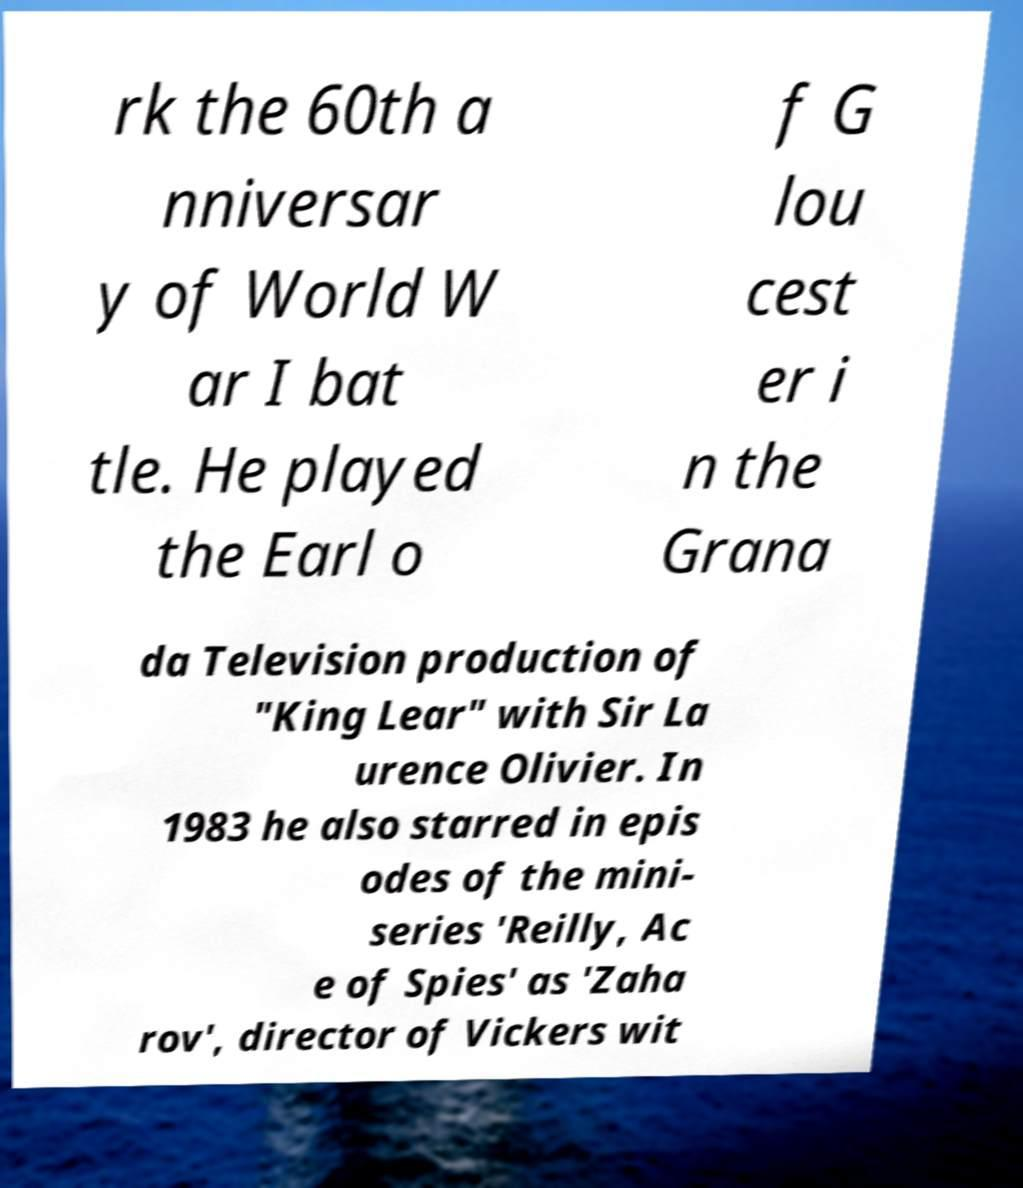Can you read and provide the text displayed in the image?This photo seems to have some interesting text. Can you extract and type it out for me? rk the 60th a nniversar y of World W ar I bat tle. He played the Earl o f G lou cest er i n the Grana da Television production of "King Lear" with Sir La urence Olivier. In 1983 he also starred in epis odes of the mini- series 'Reilly, Ac e of Spies' as 'Zaha rov', director of Vickers wit 